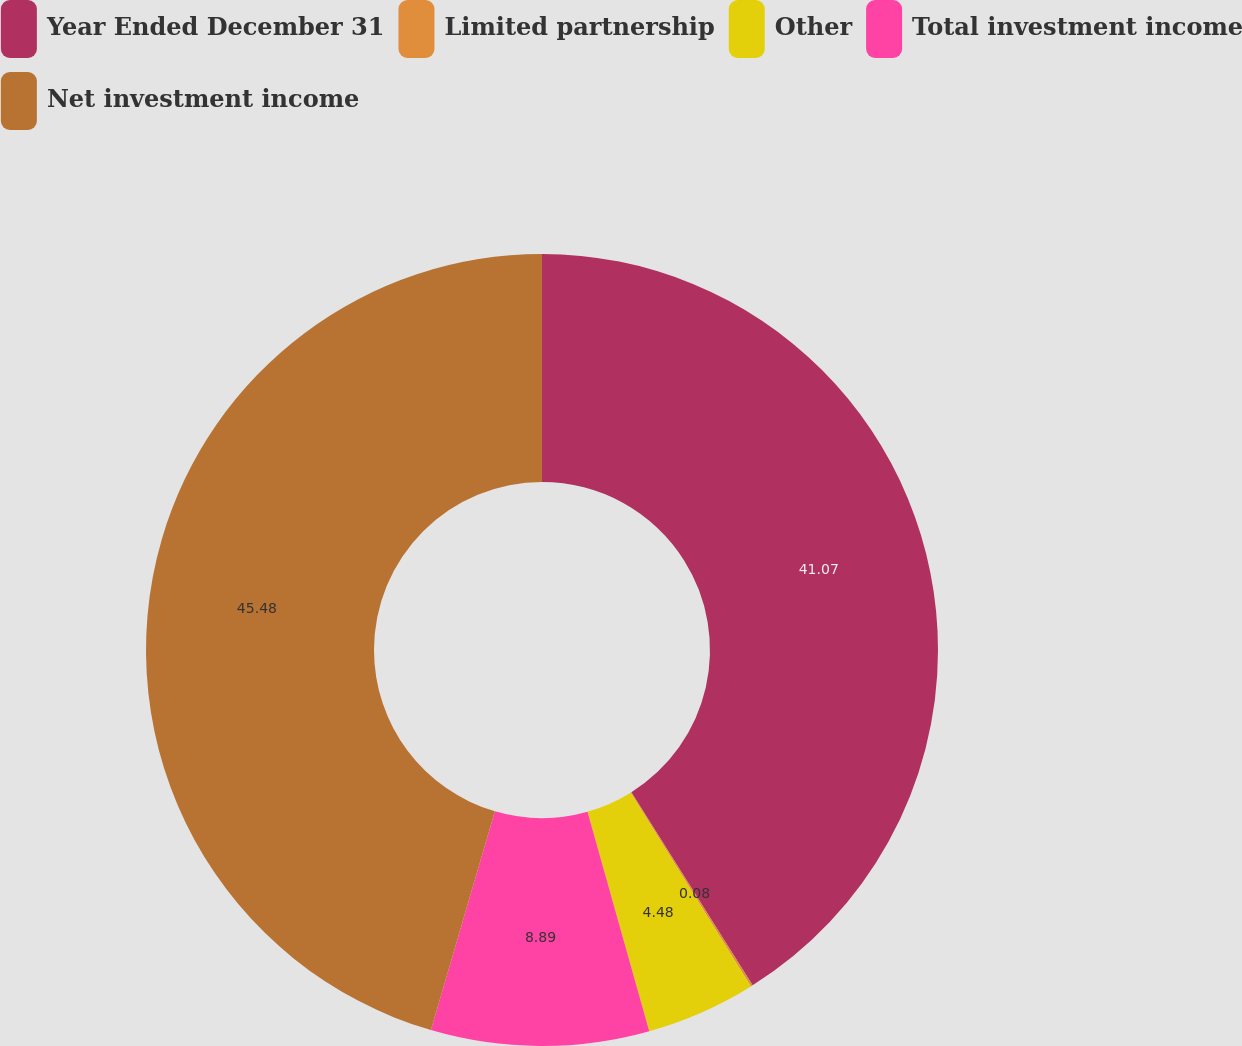<chart> <loc_0><loc_0><loc_500><loc_500><pie_chart><fcel>Year Ended December 31<fcel>Limited partnership<fcel>Other<fcel>Total investment income<fcel>Net investment income<nl><fcel>41.07%<fcel>0.08%<fcel>4.48%<fcel>8.89%<fcel>45.47%<nl></chart> 